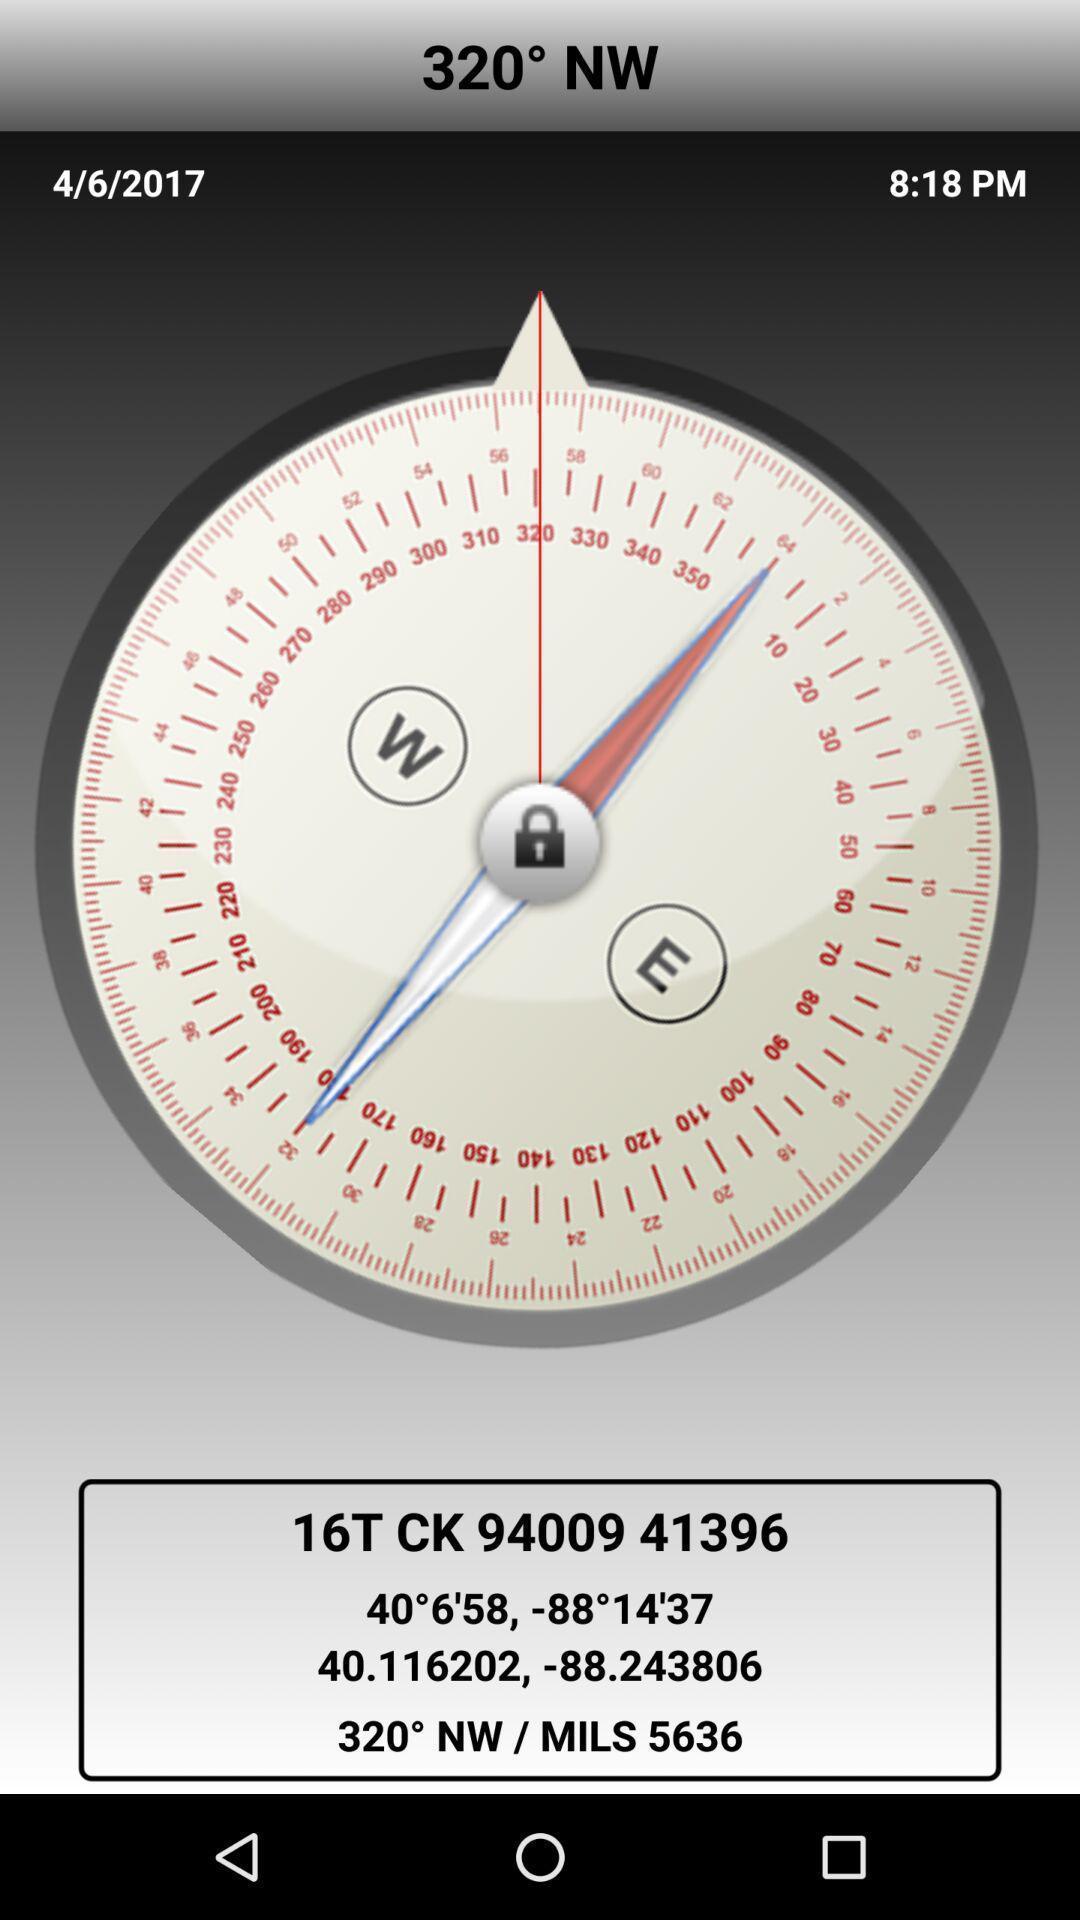What details can you identify in this image? Window displaying with all geography coordinates. 